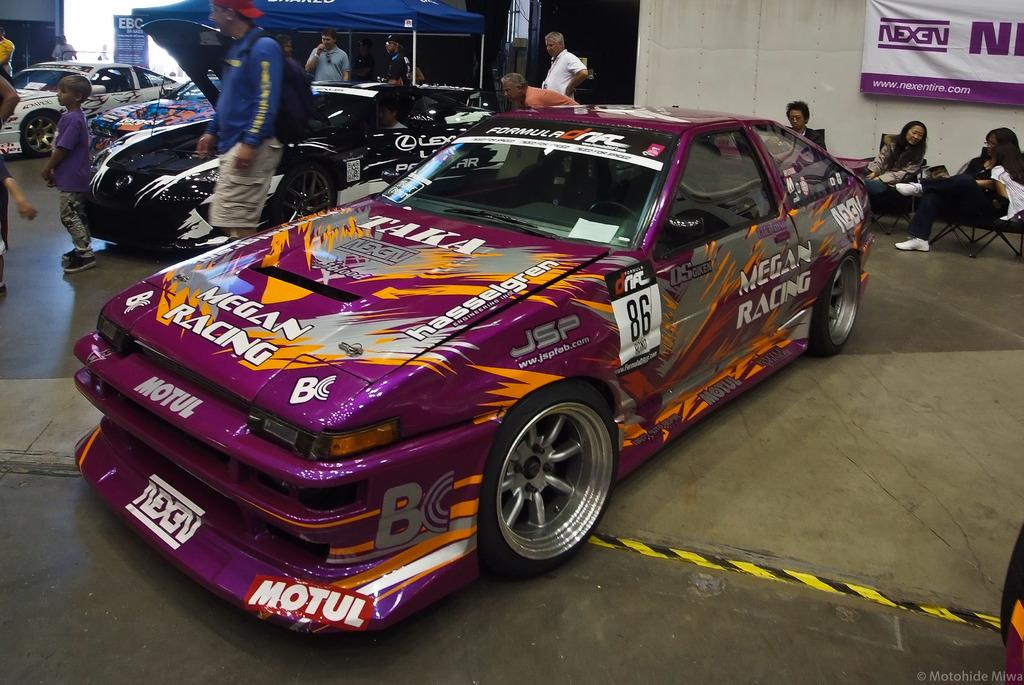What type of vehicles can be seen in the image? There are cars in the image. Are there any people present in the image? Yes, there are people in the image. What can be seen on the wall in the image? There is a poster on a wall in the image. How many pigs are visible in the image? There are no pigs present in the image. What type of worm can be seen crawling on the poster in the image? There is no worm present in the image, and the poster is not mentioned to have any worms on it. 